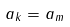<formula> <loc_0><loc_0><loc_500><loc_500>a _ { k } = a _ { m }</formula> 